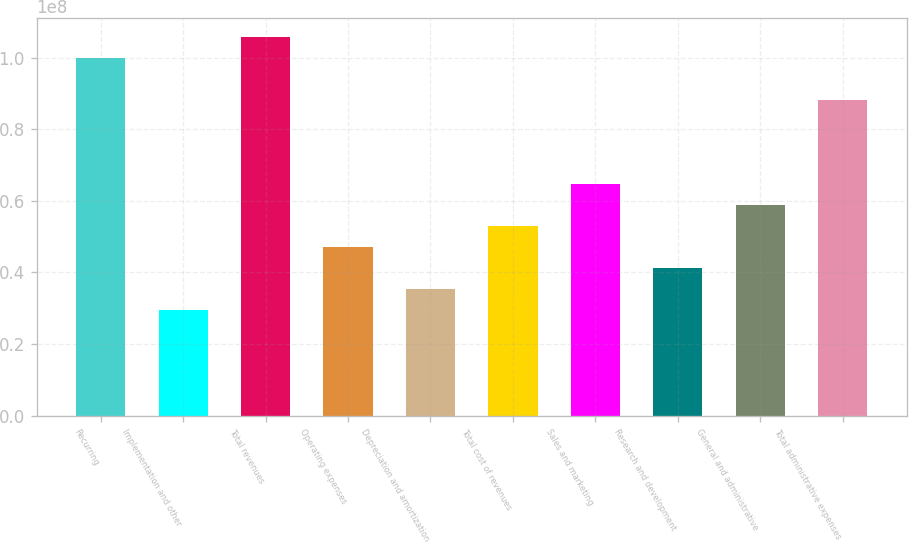Convert chart to OTSL. <chart><loc_0><loc_0><loc_500><loc_500><bar_chart><fcel>Recurring<fcel>Implementation and other<fcel>Total revenues<fcel>Operating expenses<fcel>Depreciation and amortization<fcel>Total cost of revenues<fcel>Sales and marketing<fcel>Research and development<fcel>General and administrative<fcel>Total administrative expenses<nl><fcel>9.9943e+07<fcel>2.9395e+07<fcel>1.05822e+08<fcel>4.7032e+07<fcel>3.5274e+07<fcel>5.2911e+07<fcel>6.4669e+07<fcel>4.1153e+07<fcel>5.879e+07<fcel>8.8185e+07<nl></chart> 